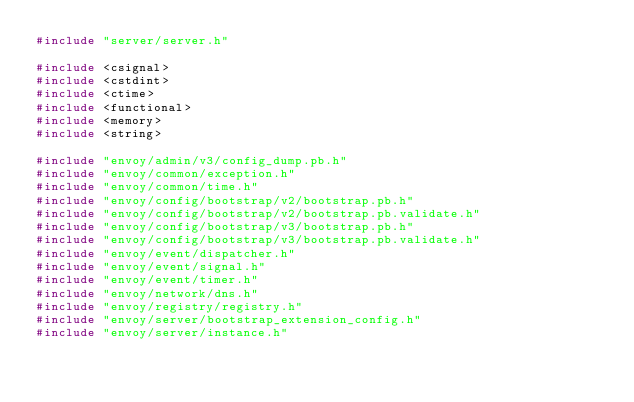Convert code to text. <code><loc_0><loc_0><loc_500><loc_500><_C++_>#include "server/server.h"

#include <csignal>
#include <cstdint>
#include <ctime>
#include <functional>
#include <memory>
#include <string>

#include "envoy/admin/v3/config_dump.pb.h"
#include "envoy/common/exception.h"
#include "envoy/common/time.h"
#include "envoy/config/bootstrap/v2/bootstrap.pb.h"
#include "envoy/config/bootstrap/v2/bootstrap.pb.validate.h"
#include "envoy/config/bootstrap/v3/bootstrap.pb.h"
#include "envoy/config/bootstrap/v3/bootstrap.pb.validate.h"
#include "envoy/event/dispatcher.h"
#include "envoy/event/signal.h"
#include "envoy/event/timer.h"
#include "envoy/network/dns.h"
#include "envoy/registry/registry.h"
#include "envoy/server/bootstrap_extension_config.h"
#include "envoy/server/instance.h"</code> 